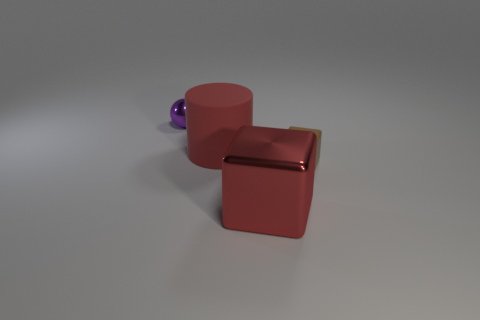Is there a tiny block that has the same color as the shiny sphere?
Offer a terse response. No. What is the size of the purple object that is made of the same material as the big cube?
Offer a terse response. Small. Does the large metallic object have the same color as the tiny metal ball?
Your answer should be compact. No. Is the shape of the tiny thing that is in front of the tiny shiny sphere the same as  the large matte object?
Keep it short and to the point. No. How many brown rubber objects are the same size as the red matte thing?
Your response must be concise. 0. What shape is the other large thing that is the same color as the large shiny object?
Your answer should be compact. Cylinder. Is there a purple shiny sphere left of the tiny thing behind the brown rubber cube?
Your answer should be very brief. No. What number of objects are blocks in front of the small matte thing or matte things?
Your answer should be very brief. 3. How many metal objects are there?
Your response must be concise. 2. The thing that is made of the same material as the tiny brown block is what shape?
Your answer should be very brief. Cylinder. 